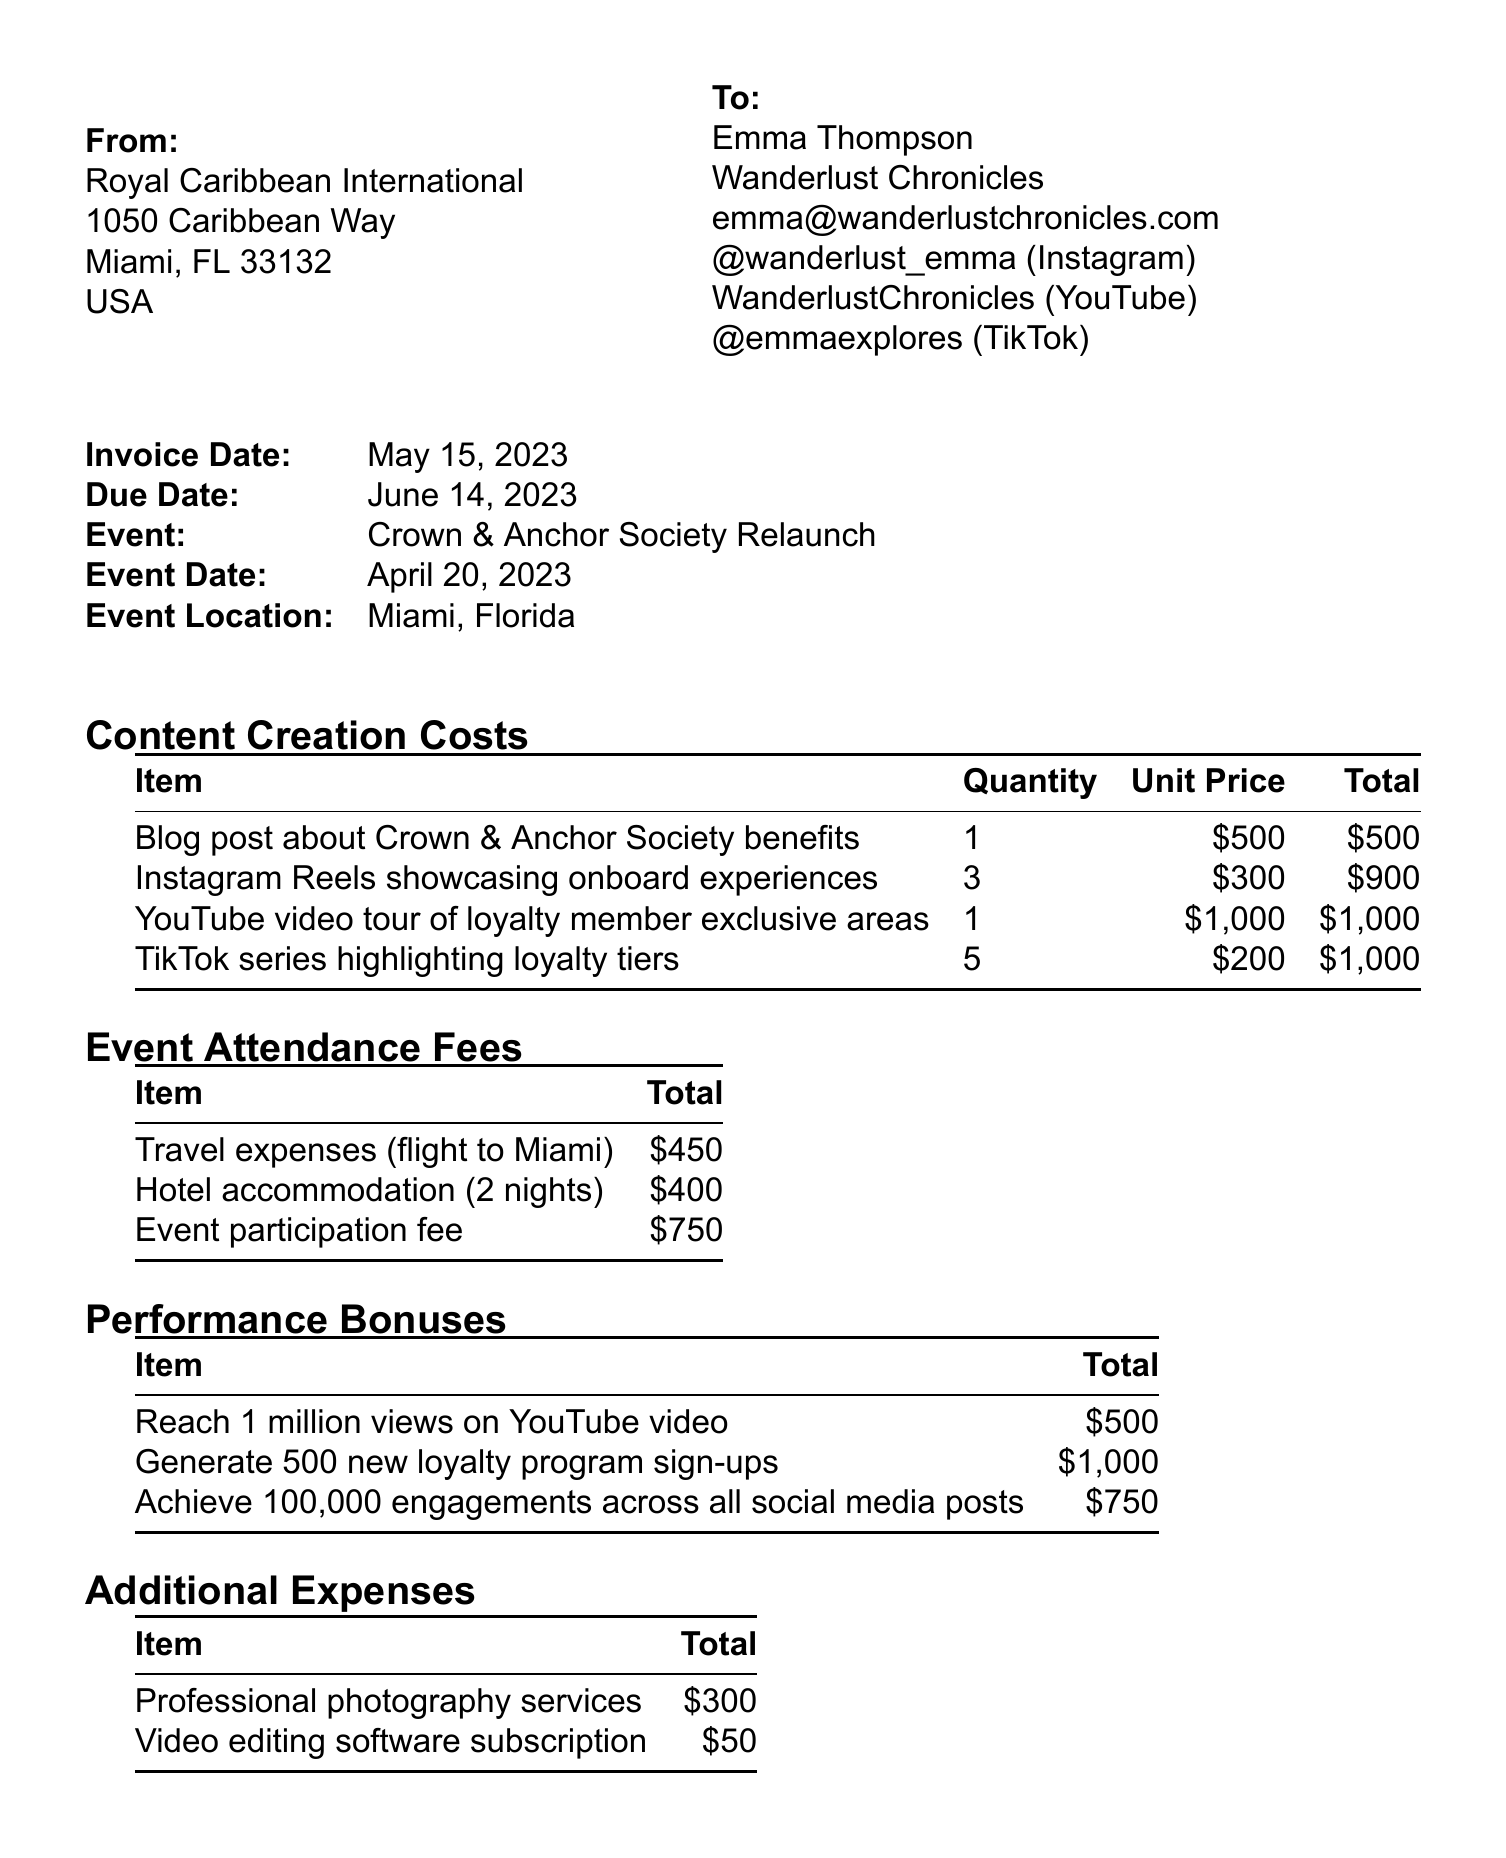What is the invoice number? The invoice number is explicitly mentioned in the document.
Answer: INV-2023-0542 Who is the travel blogger? The travel blogger's name is listed in the travel blogger information section.
Answer: Emma Thompson What is the total due amount? The total due is located in the payment details section toward the end of the document.
Answer: $8,208.00 What is the event participation fee? The event participation fee is part of the event attendance fees outlined in the document.
Answer: $750 How many Instagram Reels were created? The quantity for Instagram Reels is specified under content creation costs.
Answer: 3 What is the tax rate applied? The tax rate is mentioned in the payment details section of the document.
Answer: 8% What is the due date of the invoice? The due date is provided clearly in the invoice details section.
Answer: June 14, 2023 What are the total performance bonuses? Total performance bonuses are calculated from multiple items detailed in the performance bonuses section.
Answer: $2,250 What payment method is specified? The payment method is indicated in the payment details section.
Answer: Bank transfer 